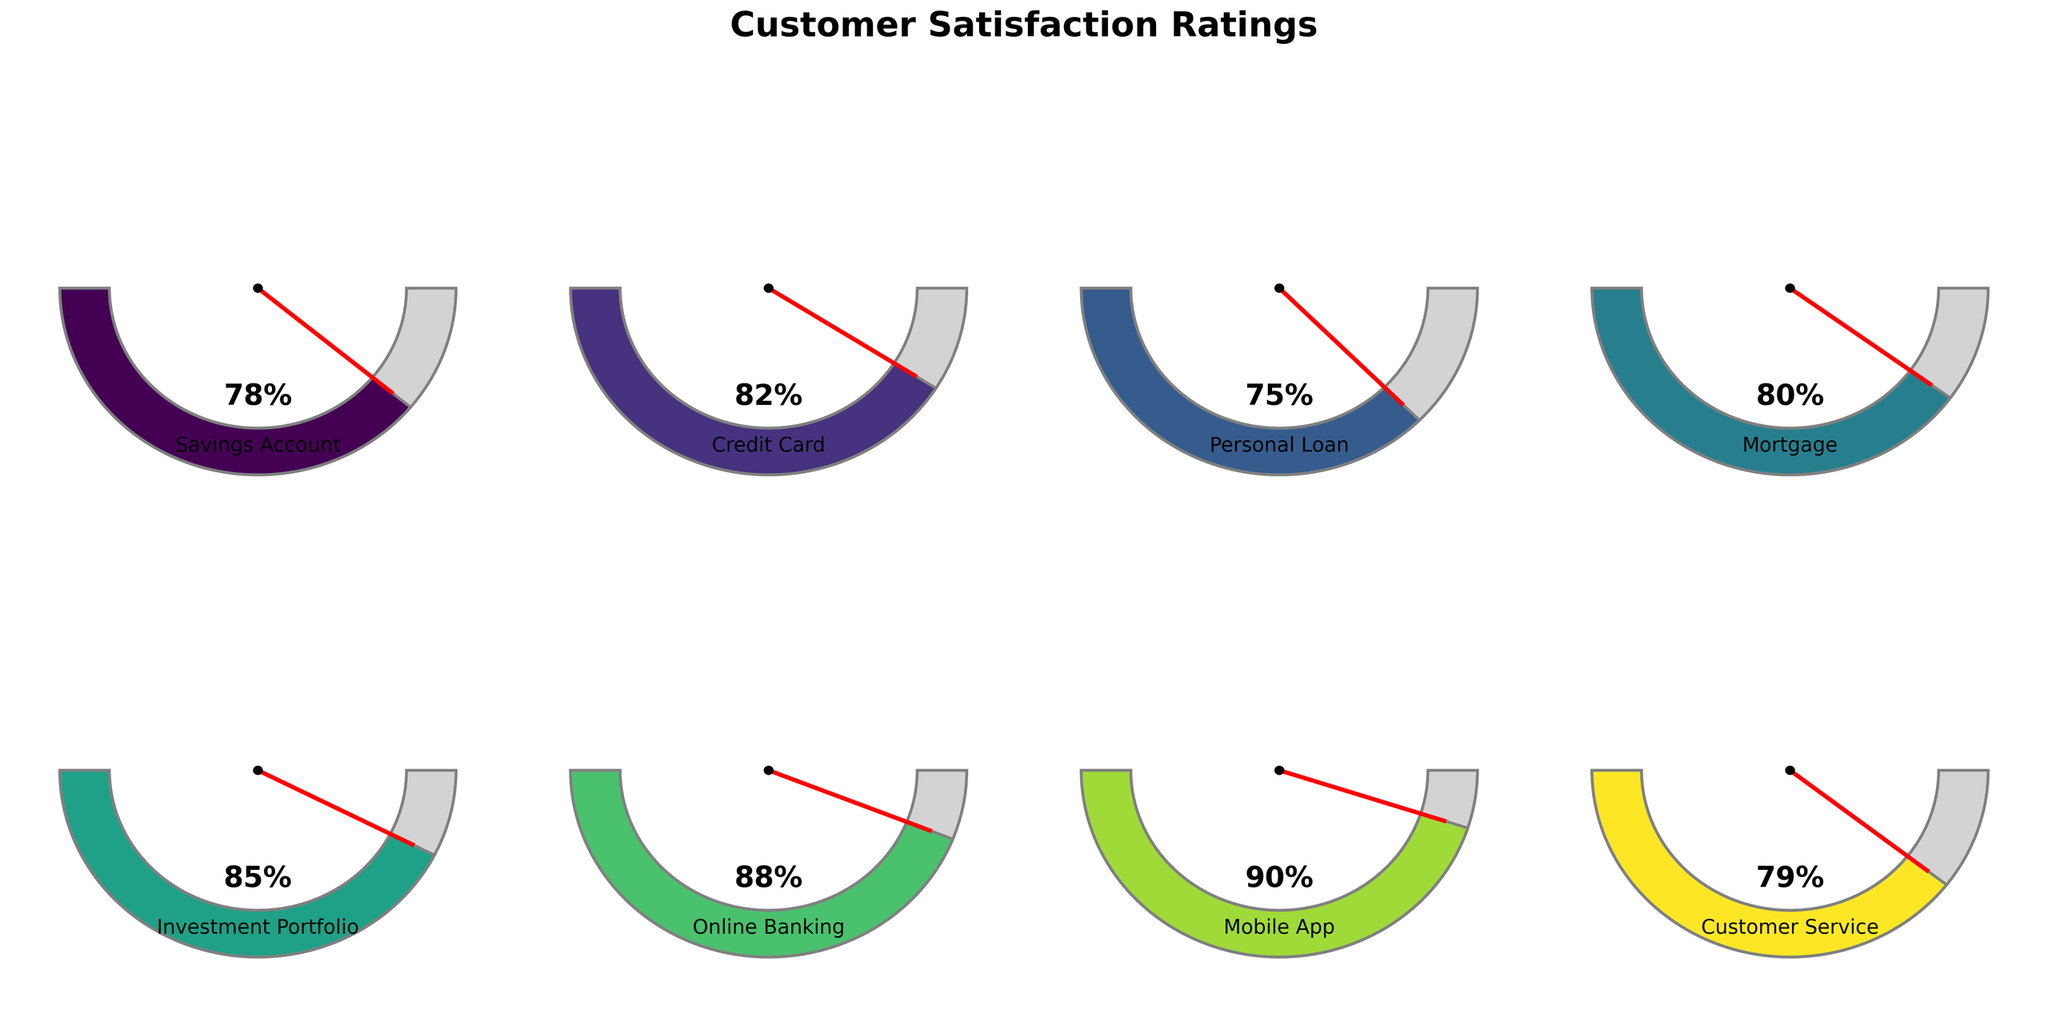What's the title of the figure? The title of the figure is located at the top and reads "Customer Satisfaction Ratings".
Answer: Customer Satisfaction Ratings Which product has the highest satisfaction rating? Look for the gauge chart with the needle pointing at the highest percentage number. The Mobile App has a 90% satisfaction rating.
Answer: Mobile App What is the satisfaction rating for Credit Card? Find the gauge labeled with "Credit Card" and note the percentage shown on the chart. The Credit Card has a satisfaction rating of 82%.
Answer: 82% Which two products have their ratings closest to each other? Compare each gauge chart's ratings and find the two with the smallest percentage difference. The Credit Card (82%) and Mortgage (80%) have the closest ratings.
Answer: Credit Card and Mortgage What's the difference in satisfaction ratings between Online Banking and Customer Service? Online Banking satisfaction rating is 88%, and Customer Service is 79%. Subtract the smaller value from the larger one: 88% - 79% = 9%.
Answer: 9% What is the average satisfaction rating of all the products? Sum all the satisfaction ratings: 78 + 82 + 75 + 80 + 85 + 88 + 90 + 79 = 657. Then divide by the total number of products, 657 / 8 = 82.125%.
Answer: 82.125% Which product has a higher satisfaction rating, Savings Account or Personal Loan? Compare the ratings: Savings Account is 78%, Personal Loan is 75%. The Savings Account has a higher rating.
Answer: Savings Account How many products have a satisfaction rating above 80%? Identify the products with ratings above 80%: Credit Card (82%), Mortgage (80%), Investment Portfolio (85%), Online Banking (88%), and Mobile App (90%). Five products are above 80%.
Answer: 5 What is the range of the satisfaction ratings across all products? Find the highest and lowest ratings: Mobile App (90%) and Personal Loan (75%). Subtract the smallest value from the largest one: 90% - 75% = 15%.
Answer: 15% 